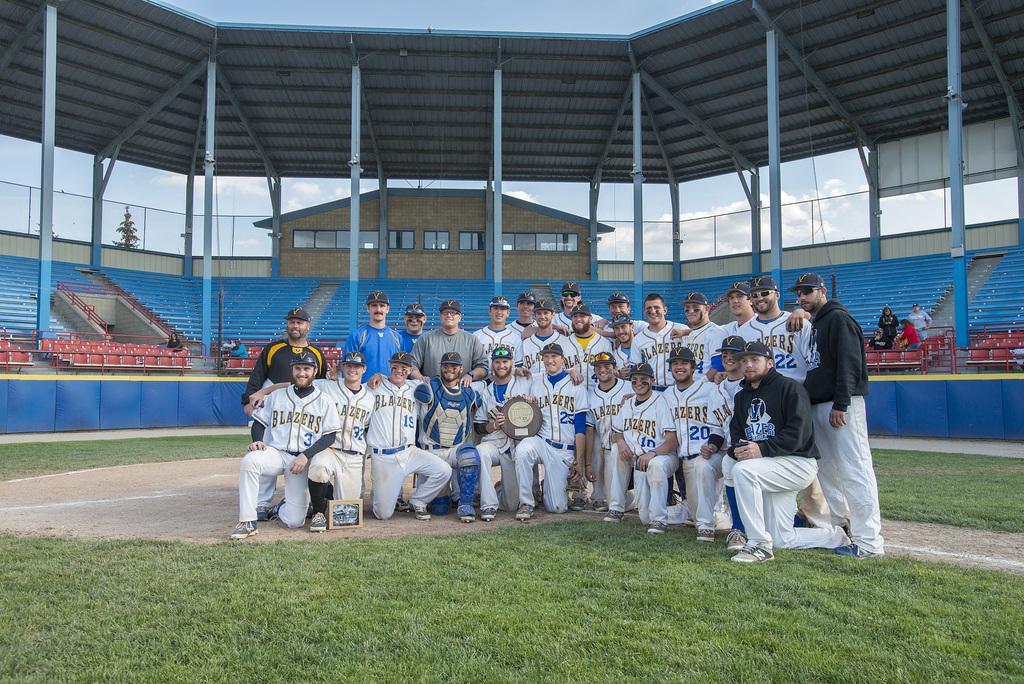What is this baseball team's name?
Your answer should be compact. Blazers. How many people are in the squad?
Your response must be concise. 27. 